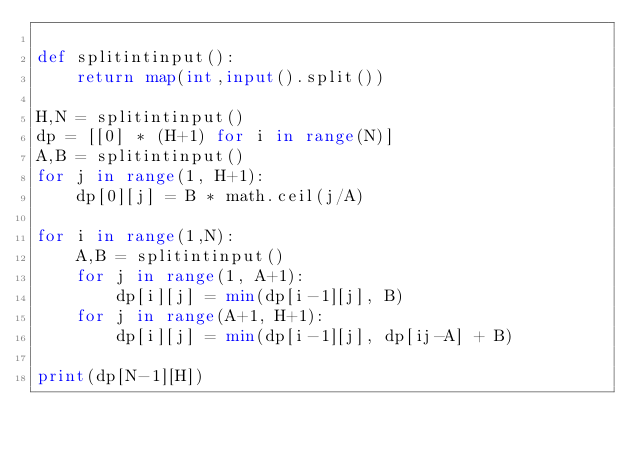<code> <loc_0><loc_0><loc_500><loc_500><_Python_>
def splitintinput():
    return map(int,input().split())

H,N = splitintinput()
dp = [[0] * (H+1) for i in range(N)]
A,B = splitintinput()
for j in range(1, H+1):
    dp[0][j] = B * math.ceil(j/A)

for i in range(1,N):
    A,B = splitintinput()
    for j in range(1, A+1):
        dp[i][j] = min(dp[i-1][j], B)
    for j in range(A+1, H+1):
        dp[i][j] = min(dp[i-1][j], dp[ij-A] + B)

print(dp[N-1][H])</code> 